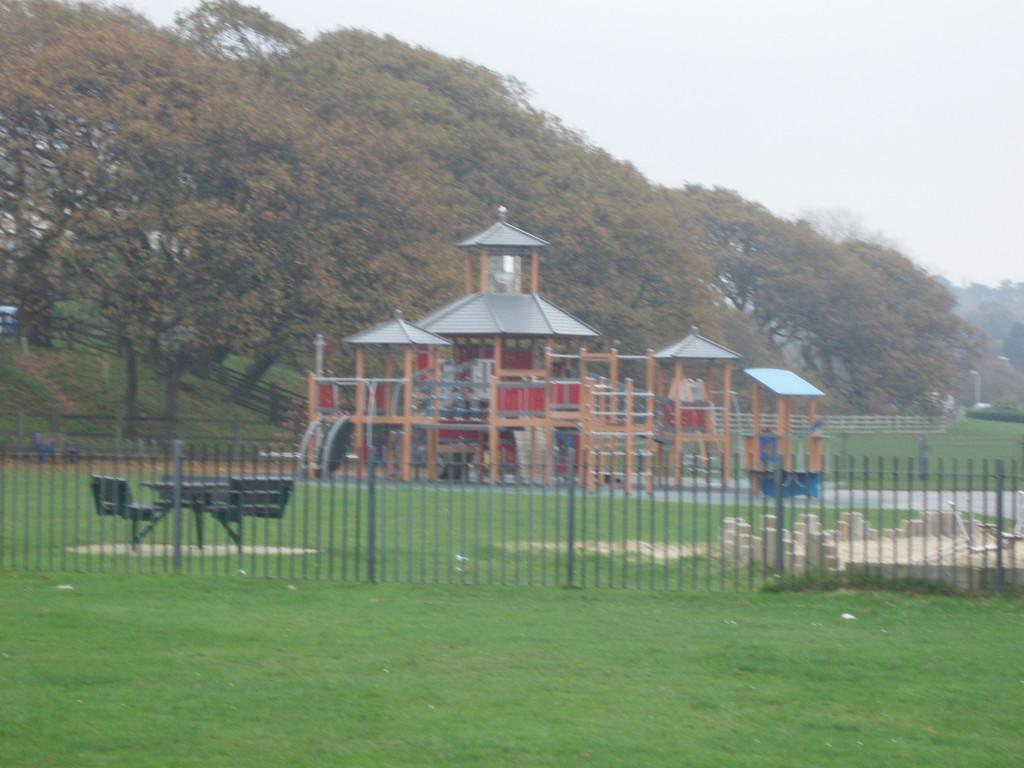What can be seen in the foreground of the image? In the foreground of the image, there is a railing and grass. What is visible in the background of the image? In the background of the image, there are chairs, tables, a gaming house, trees, and the sky. How many types of furniture are present in the background of the image? There are two types of furniture present in the background of the image: chairs and tables. What type of establishment is visible in the background of the image? A gaming house is visible in the background of the image. How many balls are visible in the image? There are no balls present in the image. What type of spot is visible on the sun in the image? There is no sun visible in the image, and therefore no spots can be observed. 